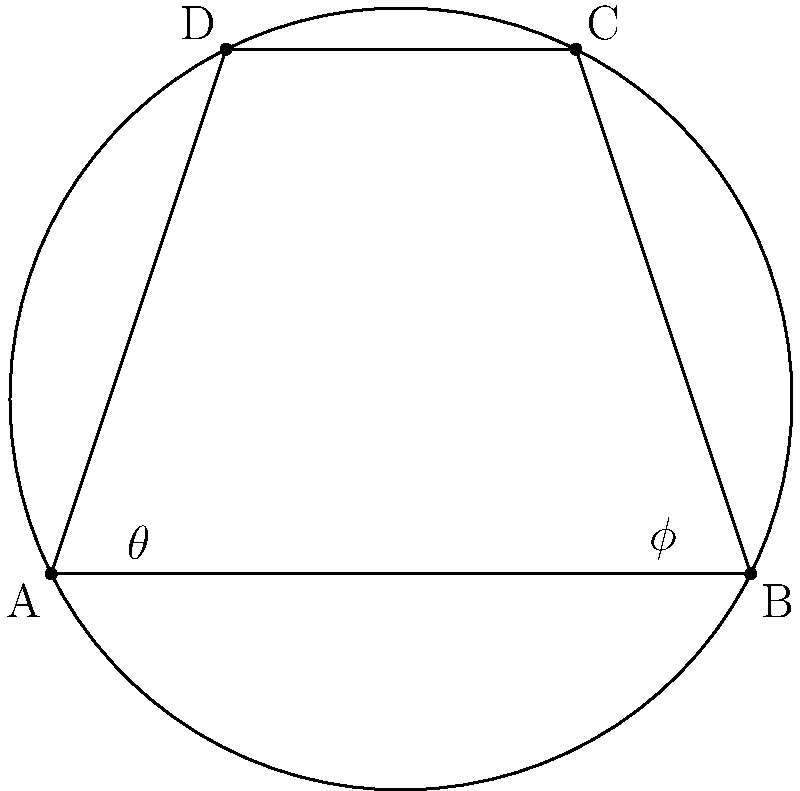In the cyclic quadrilateral ABCD inscribed in a circle, angles BAD and BCD are denoted as $\theta$ and $\phi$ respectively. If $\theta = 40°$, what is the value of $\phi$? How does this relationship reflect the nature of uncertainty and calculated risks in both poker and life? Let's approach this step-by-step:

1) In a cyclic quadrilateral, opposite angles are supplementary. This means:
   $$\angle BAD + \angle BCD = 180°$$

2) We are given that $\theta = 40°$, so:
   $$40° + \phi = 180°$$

3) Solving for $\phi$:
   $$\phi = 180° - 40° = 140°$$

This relationship in cyclic quadrilaterals reflects the nature of uncertainty and calculated risks in poker and life in several ways:

1) Complementary nature: Just as opposite angles in a cyclic quadrilateral are supplementary, success in poker and life often requires balancing different aspects. For example, aggressive play vs. cautious play in poker, or risk-taking vs. stability in life decisions.

2) Interconnectedness: Changing one angle affects the others, similar to how decisions in poker or life can have far-reaching consequences.

3) Hidden structure: The relationship between angles isn't immediately obvious, much like the hidden patterns and probabilities in poker, or the underlying structures in life situations.

4) Calculated risks: Understanding these geometric relationships allows for precise predictions, just as understanding probabilities in poker or potential outcomes in life decisions allows for calculated risk-taking.

5) Embracing uncertainty: While the relationship is fixed, the specific angles can vary widely, reflecting how embracing uncertainty can lead to diverse outcomes and opportunities.
Answer: $\phi = 140°$ 